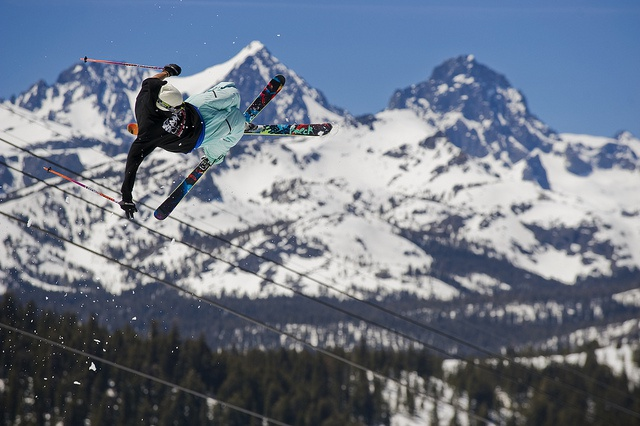Describe the objects in this image and their specific colors. I can see people in blue, black, darkgray, teal, and gray tones and skis in blue, black, darkgray, gray, and teal tones in this image. 